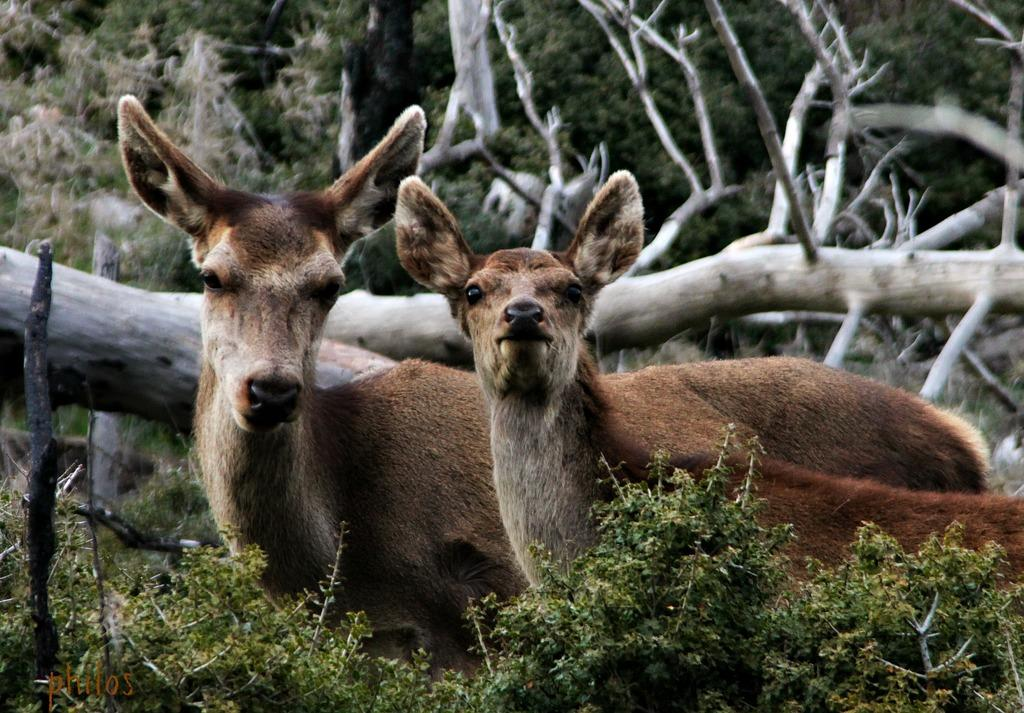What types of living organisms can be seen in the image? There are animals in the image. What is located at the bottom of the image? There are plants at the bottom of the image. What is present throughout the image? There is a watermark in the image. What can be seen in the background of the image? There are trees and wooden logs in the background of the image. Can you see any boats in the image? There are no boats present in the image. What type of copy machine is used to create the image? The image does not contain any information about the copy machine used to create it. 